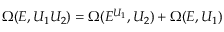<formula> <loc_0><loc_0><loc_500><loc_500>\Omega ( E , U _ { 1 } U _ { 2 } ) = \Omega ( E ^ { U _ { 1 } } , U _ { 2 } ) + \Omega ( E , U _ { 1 } )</formula> 